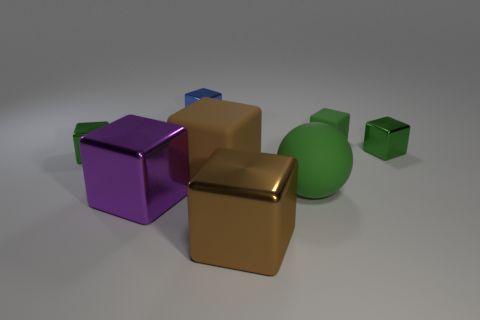Subtract all green cylinders. How many green blocks are left? 3 Subtract all blue blocks. How many blocks are left? 6 Subtract all tiny green shiny cubes. How many cubes are left? 5 Subtract all gray blocks. Subtract all yellow cylinders. How many blocks are left? 7 Add 2 tiny green metal cubes. How many objects exist? 10 Subtract all spheres. How many objects are left? 7 Add 2 small objects. How many small objects exist? 6 Subtract 0 gray cubes. How many objects are left? 8 Subtract all purple shiny cubes. Subtract all tiny green metallic things. How many objects are left? 5 Add 4 green matte objects. How many green matte objects are left? 6 